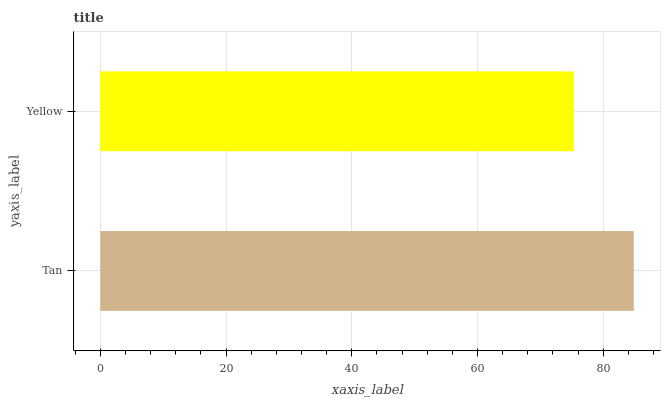Is Yellow the minimum?
Answer yes or no. Yes. Is Tan the maximum?
Answer yes or no. Yes. Is Yellow the maximum?
Answer yes or no. No. Is Tan greater than Yellow?
Answer yes or no. Yes. Is Yellow less than Tan?
Answer yes or no. Yes. Is Yellow greater than Tan?
Answer yes or no. No. Is Tan less than Yellow?
Answer yes or no. No. Is Tan the high median?
Answer yes or no. Yes. Is Yellow the low median?
Answer yes or no. Yes. Is Yellow the high median?
Answer yes or no. No. Is Tan the low median?
Answer yes or no. No. 